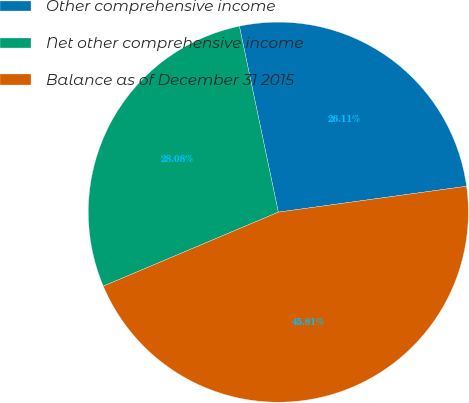<chart> <loc_0><loc_0><loc_500><loc_500><pie_chart><fcel>Other comprehensive income<fcel>Net other comprehensive income<fcel>Balance as of December 31 2015<nl><fcel>26.11%<fcel>28.08%<fcel>45.81%<nl></chart> 